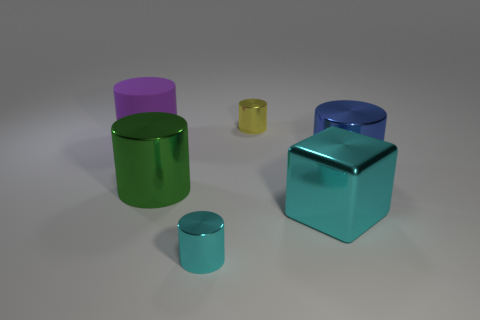What is the material of the small cylinder that is behind the cylinder to the right of the tiny cylinder that is behind the cube?
Make the answer very short. Metal. How many things are either cylinders or tiny objects behind the big purple rubber object?
Your answer should be very brief. 5. There is a shiny cylinder that is behind the purple matte cylinder; is its color the same as the rubber cylinder?
Make the answer very short. No. Is the number of tiny metal objects in front of the rubber object greater than the number of tiny objects in front of the big blue thing?
Your answer should be very brief. No. Is there anything else of the same color as the matte thing?
Give a very brief answer. No. How many things are large blue metallic objects or shiny things?
Provide a succinct answer. 5. There is a metallic thing behind the matte cylinder; does it have the same size as the big blue cylinder?
Offer a terse response. No. How many other objects are there of the same size as the blue cylinder?
Provide a short and direct response. 3. Are any tiny metal cylinders visible?
Your answer should be compact. Yes. What size is the blue metallic object behind the cyan thing to the left of the large cyan object?
Offer a terse response. Large. 